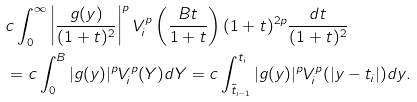<formula> <loc_0><loc_0><loc_500><loc_500>& c \int _ { 0 } ^ { \infty } \left | \frac { g ( y ) } { ( 1 + t ) ^ { 2 } } \right | ^ { p } V _ { i } ^ { p } \left ( \frac { B t } { 1 + t } \right ) ( 1 + t ) ^ { 2 p } \frac { d t } { ( 1 + t ) ^ { 2 } } \\ & = c \int _ { 0 } ^ { B } | g ( y ) | ^ { p } V _ { i } ^ { p } ( Y ) d Y = c \int _ { \bar { t } _ { i - 1 } } ^ { t _ { i } } | g ( y ) | ^ { p } V _ { i } ^ { p } ( | y - t _ { i } | ) d y .</formula> 